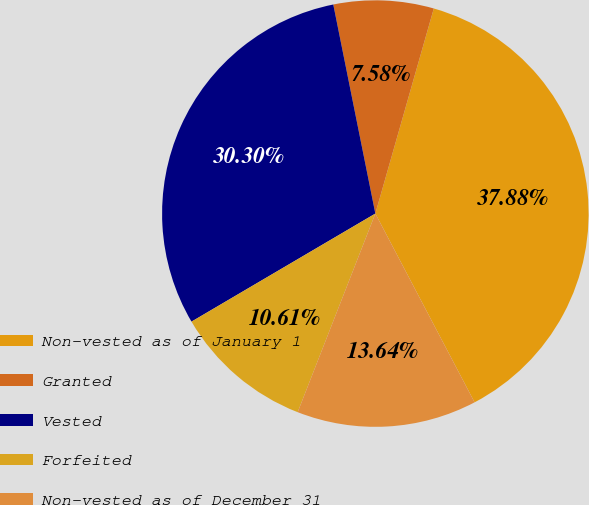<chart> <loc_0><loc_0><loc_500><loc_500><pie_chart><fcel>Non-vested as of January 1<fcel>Granted<fcel>Vested<fcel>Forfeited<fcel>Non-vested as of December 31<nl><fcel>37.88%<fcel>7.58%<fcel>30.3%<fcel>10.61%<fcel>13.64%<nl></chart> 